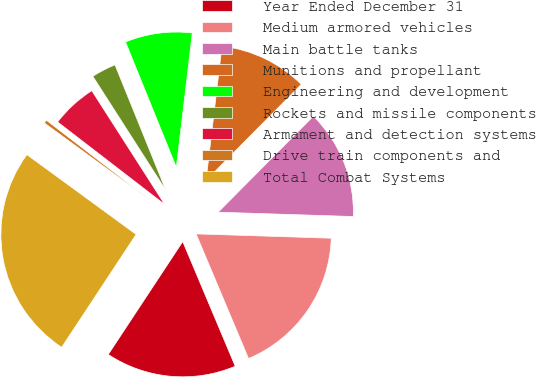<chart> <loc_0><loc_0><loc_500><loc_500><pie_chart><fcel>Year Ended December 31<fcel>Medium armored vehicles<fcel>Main battle tanks<fcel>Munitions and propellant<fcel>Engineering and development<fcel>Rockets and missile components<fcel>Armament and detection systems<fcel>Drive train components and<fcel>Total Combat Systems<nl><fcel>15.62%<fcel>18.15%<fcel>13.08%<fcel>10.55%<fcel>8.01%<fcel>2.94%<fcel>5.48%<fcel>0.41%<fcel>25.76%<nl></chart> 